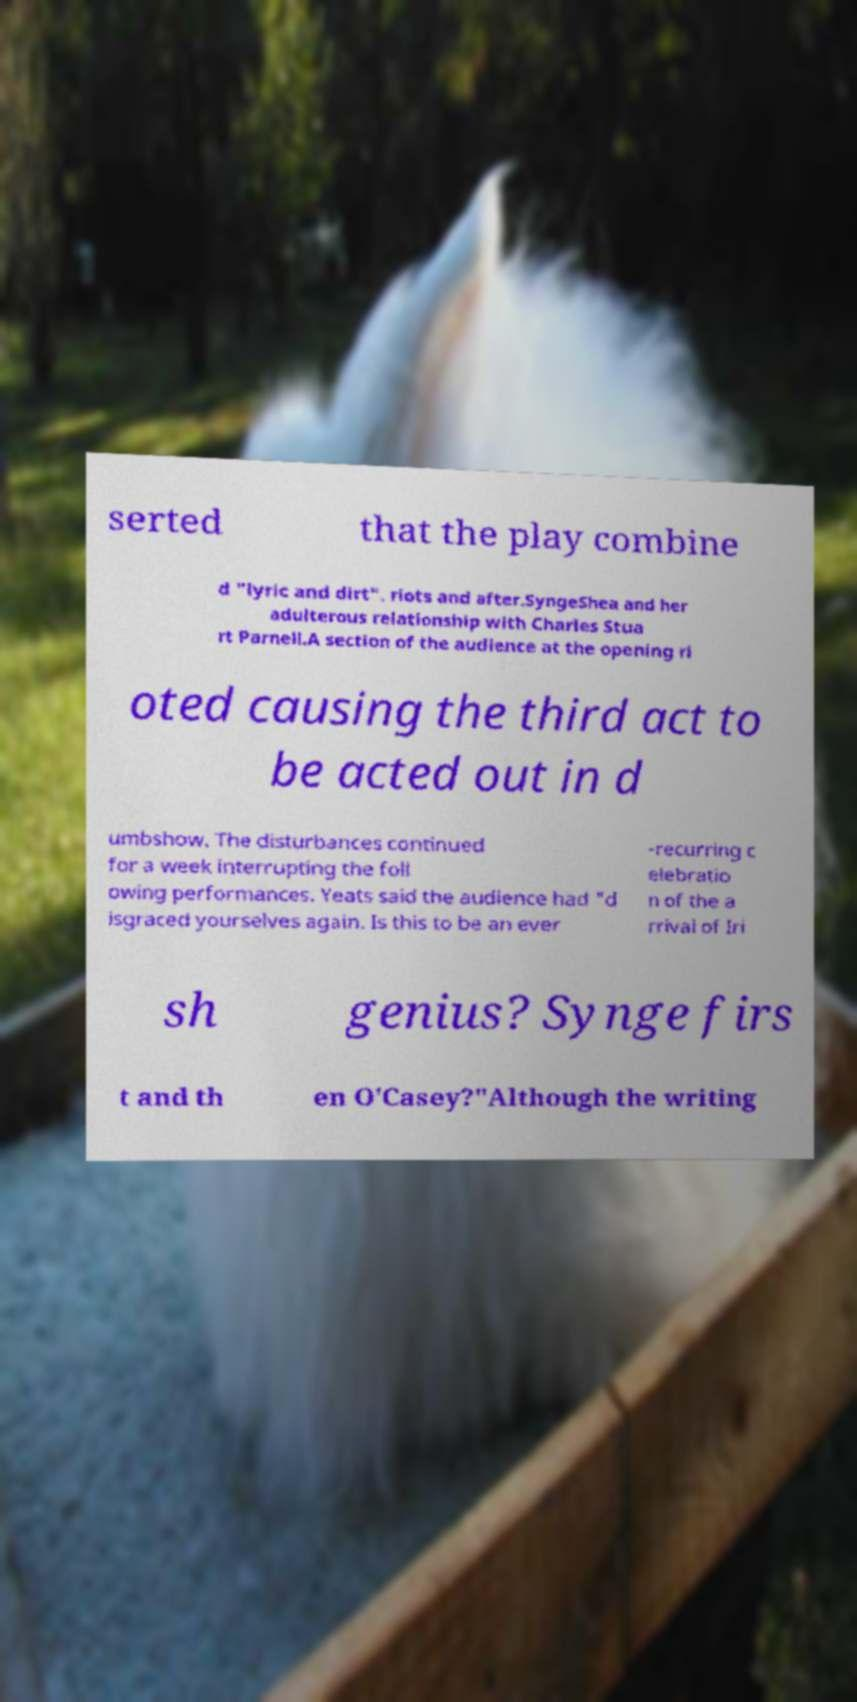I need the written content from this picture converted into text. Can you do that? serted that the play combine d "lyric and dirt". riots and after.SyngeShea and her adulterous relationship with Charles Stua rt Parnell.A section of the audience at the opening ri oted causing the third act to be acted out in d umbshow. The disturbances continued for a week interrupting the foll owing performances. Yeats said the audience had "d isgraced yourselves again. Is this to be an ever -recurring c elebratio n of the a rrival of Iri sh genius? Synge firs t and th en O'Casey?"Although the writing 